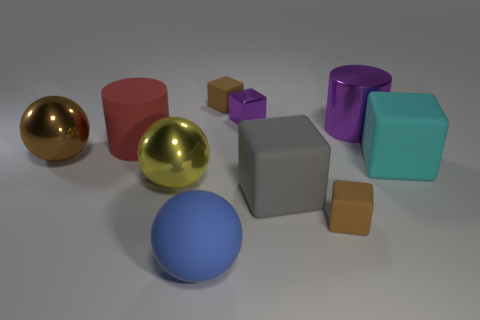What number of other things are the same size as the brown shiny sphere?
Give a very brief answer. 6. Do the tiny shiny thing and the metal cylinder have the same color?
Your answer should be very brief. Yes. What color is the object that is in front of the tiny matte cube on the right side of the brown rubber object left of the large gray rubber cube?
Your response must be concise. Blue. There is a tiny matte block that is behind the tiny block that is on the right side of the large gray matte cube; what number of blue rubber things are on the right side of it?
Make the answer very short. 0. Are there any other things that are the same color as the large rubber sphere?
Give a very brief answer. No. There is a brown block that is behind the cyan rubber object; is its size the same as the big yellow metal ball?
Keep it short and to the point. No. There is a large yellow metal object in front of the big matte cylinder; how many rubber blocks are behind it?
Your answer should be very brief. 2. There is a large gray block in front of the big cyan object to the right of the gray rubber cube; is there a cyan matte thing that is to the left of it?
Provide a succinct answer. No. There is a big blue object that is the same shape as the yellow thing; what is its material?
Provide a succinct answer. Rubber. Are the red cylinder and the tiny thing in front of the brown metal sphere made of the same material?
Offer a very short reply. Yes. 